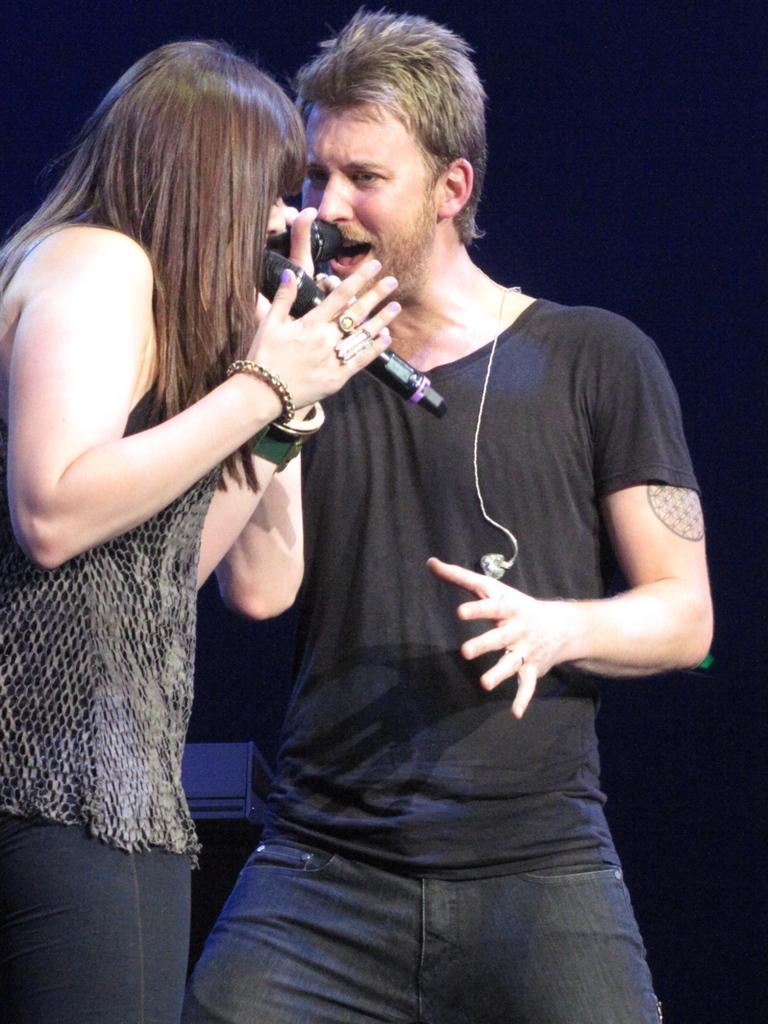How many people are in the image? There are 2 people in the image. What are the people doing in the image? The people are standing and holding microphones. Can you describe the clothing of one of the people? One person is wearing a black t-shirt and jeans. What color is the background in the image? The background is black. What type of cable can be seen connecting the microphones in the image? There is no cable connecting the microphones visible in the image. What wish does the person in the black t-shirt have while holding the microphone? There is no information about wishes or thoughts of the people in the image, as it only shows them standing and holding microphones. 